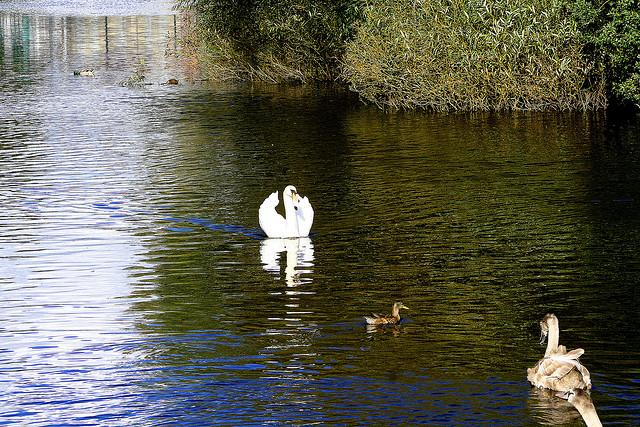What is the smaller bird in between the two larger birds?

Choices:
A) pigeon
B) duck
C) parakeet
D) parrot duck 